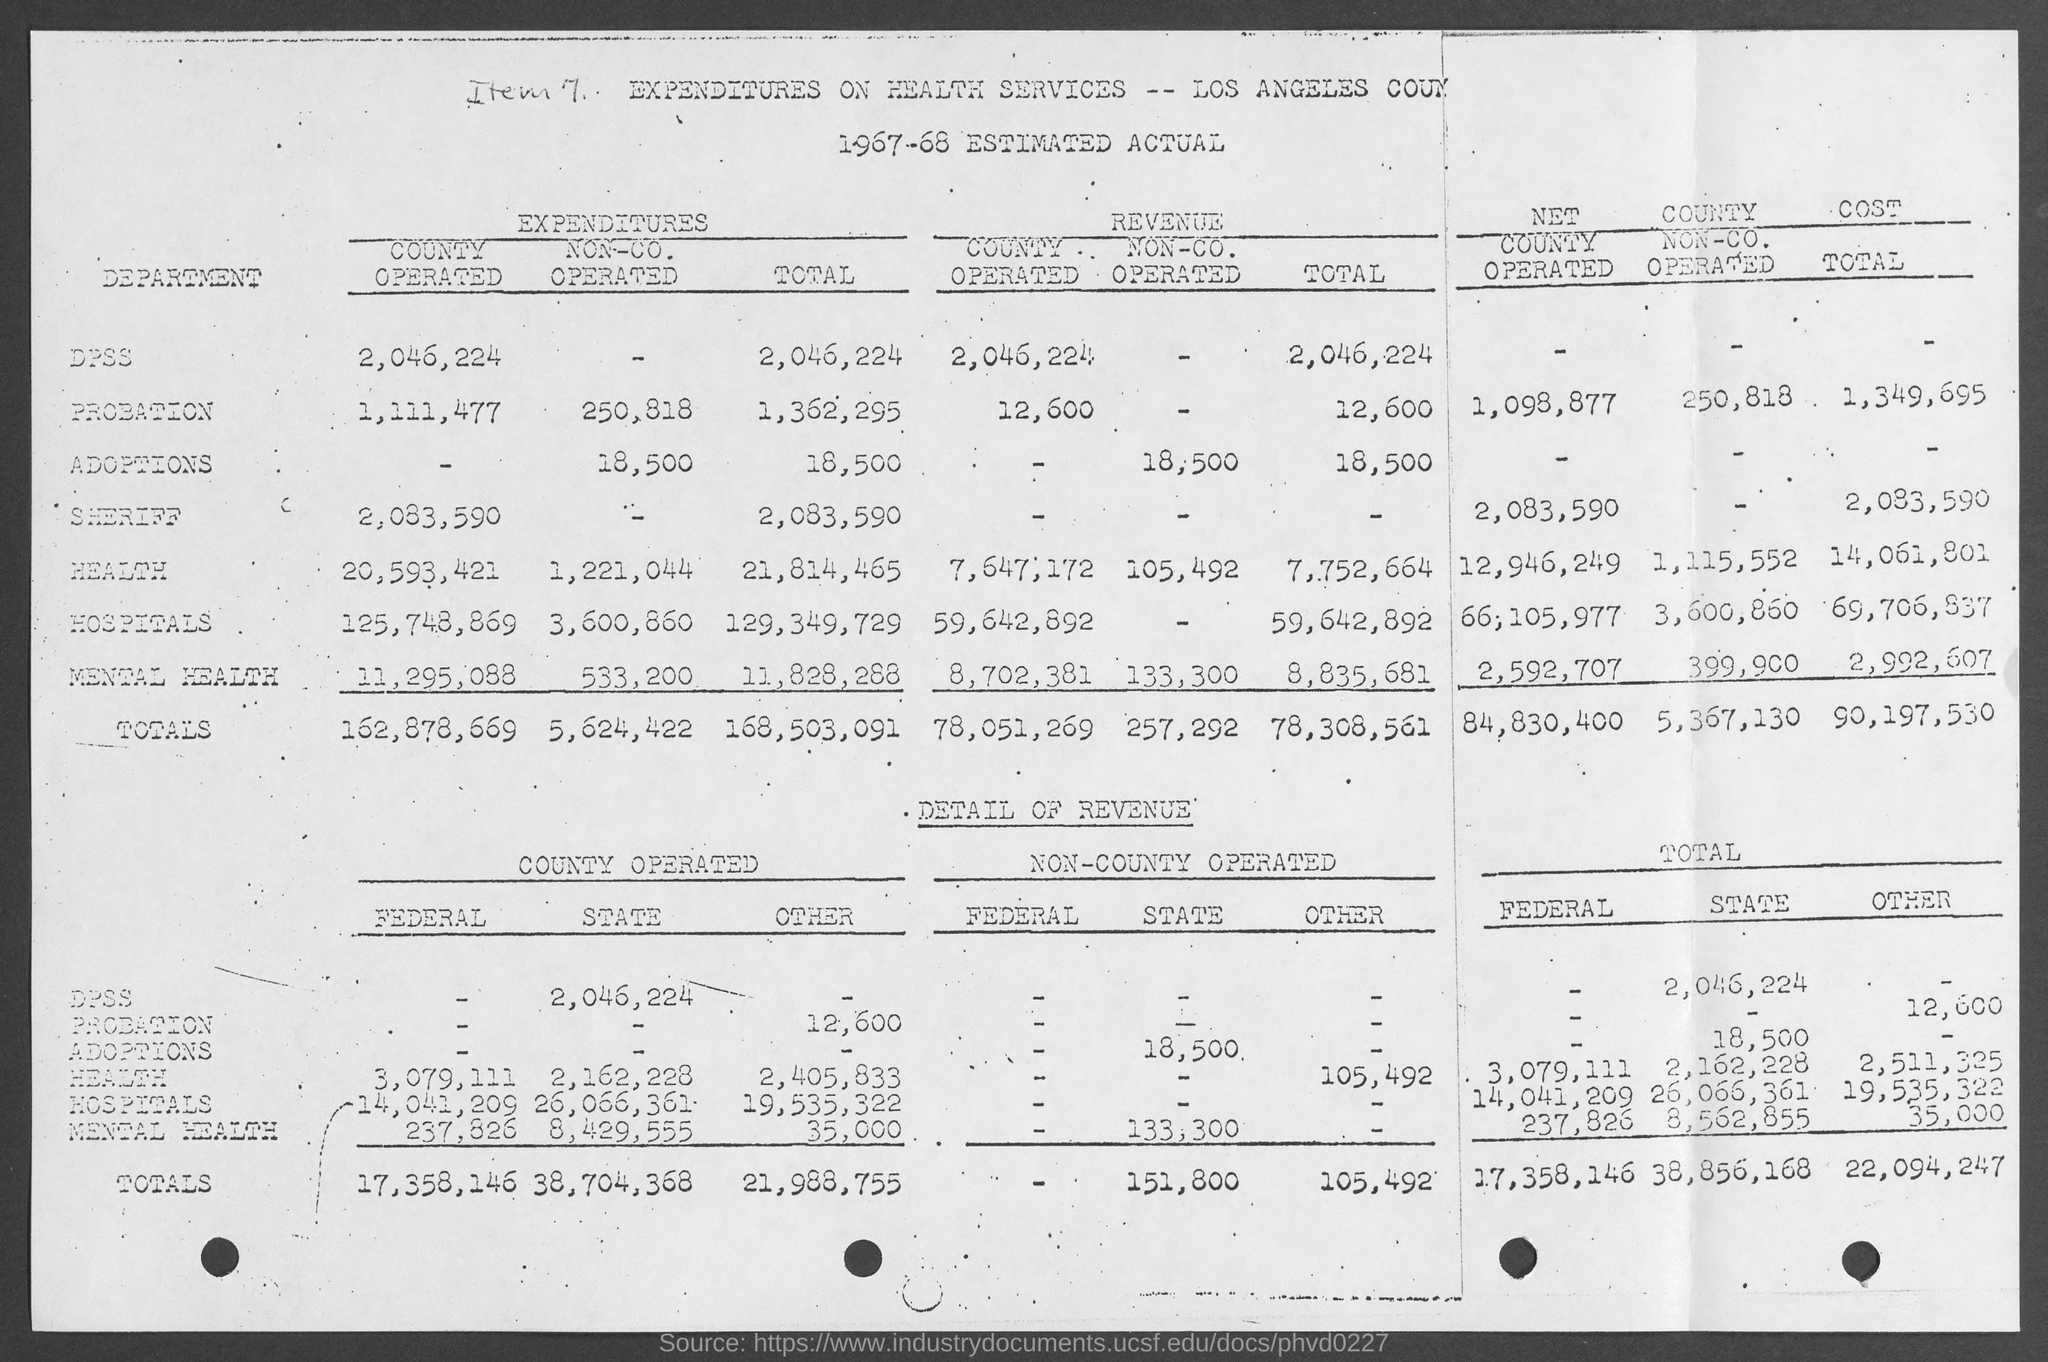Highlight a few significant elements in this photo. The total state revenue is 38,856,168. The financial year estimation is 1967-68. The total revenue is 78,308,561. The expenses for the county-operated DPSS in 2022 were approximately 2,046,224. 